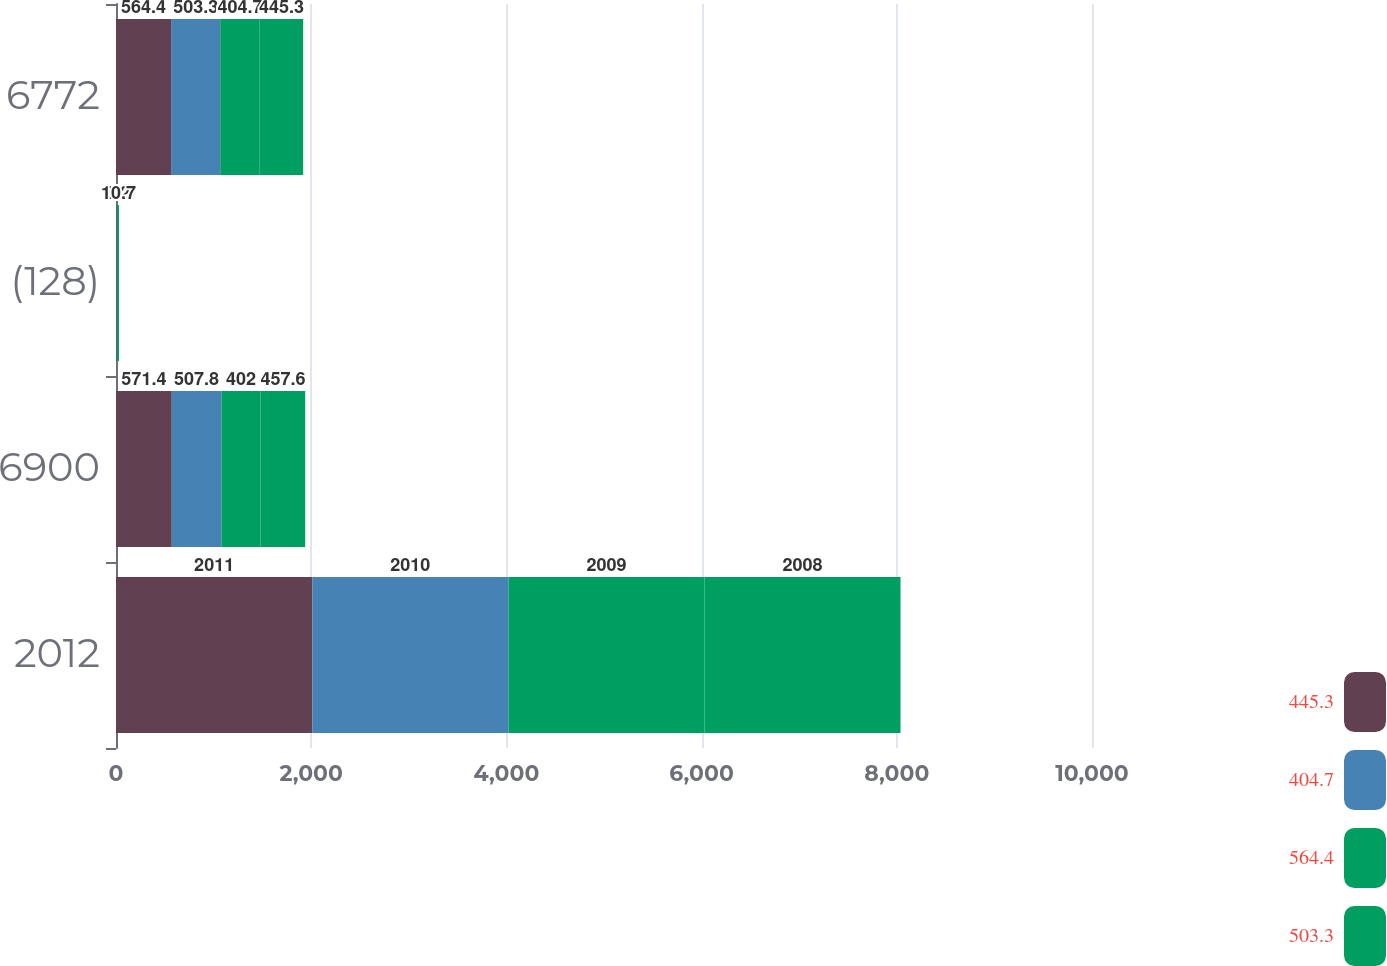Convert chart. <chart><loc_0><loc_0><loc_500><loc_500><stacked_bar_chart><ecel><fcel>2012<fcel>6900<fcel>(128)<fcel>6772<nl><fcel>445.3<fcel>2011<fcel>571.4<fcel>7<fcel>564.4<nl><fcel>404.7<fcel>2010<fcel>507.8<fcel>4.6<fcel>503.3<nl><fcel>564.4<fcel>2009<fcel>402<fcel>8.2<fcel>404.7<nl><fcel>503.3<fcel>2008<fcel>457.6<fcel>10.7<fcel>445.3<nl></chart> 